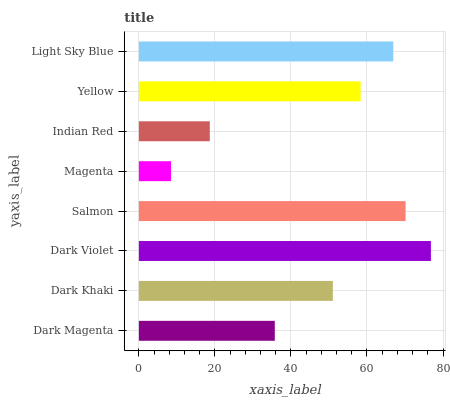Is Magenta the minimum?
Answer yes or no. Yes. Is Dark Violet the maximum?
Answer yes or no. Yes. Is Dark Khaki the minimum?
Answer yes or no. No. Is Dark Khaki the maximum?
Answer yes or no. No. Is Dark Khaki greater than Dark Magenta?
Answer yes or no. Yes. Is Dark Magenta less than Dark Khaki?
Answer yes or no. Yes. Is Dark Magenta greater than Dark Khaki?
Answer yes or no. No. Is Dark Khaki less than Dark Magenta?
Answer yes or no. No. Is Yellow the high median?
Answer yes or no. Yes. Is Dark Khaki the low median?
Answer yes or no. Yes. Is Indian Red the high median?
Answer yes or no. No. Is Magenta the low median?
Answer yes or no. No. 